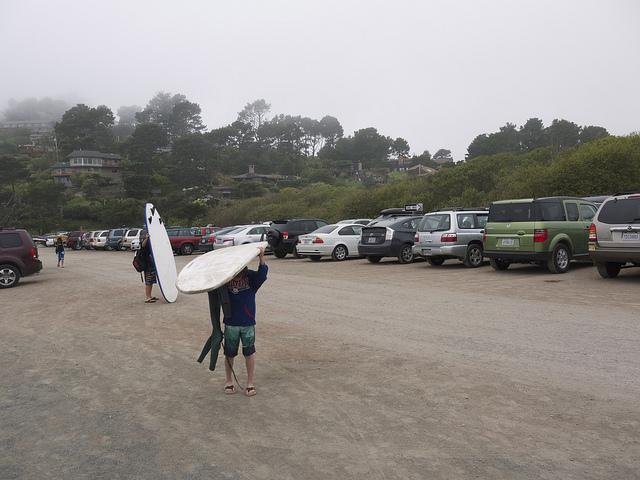Where are persons carrying the white items going? beach 